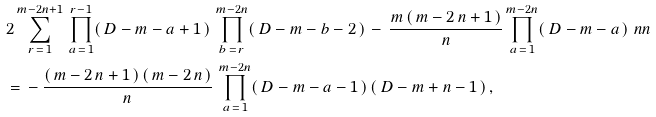<formula> <loc_0><loc_0><loc_500><loc_500>& 2 \sum _ { r \, = \, 1 } ^ { m - 2 n + 1 } \, \prod _ { a \, = \, 1 } ^ { r - 1 } ( \, D - m - a + 1 \, ) \, \prod _ { b \, = \, r } ^ { m - 2 n } ( \, D - m - b - 2 \, ) \, - \, \frac { m \, ( \, m - 2 \, n + 1 \, ) } { n } \prod _ { a \, = \, 1 } ^ { m - 2 n } ( \, D - m - a \, ) \ n n \\ & = \, - \, \frac { ( \, m - 2 \, n + 1 \, ) \, ( \, m - 2 \, n \, ) } { n } \, \prod _ { a \, = \, 1 } ^ { m - 2 n } ( \, D - m - a - 1 \, ) \, ( \, D - m + n - 1 \, ) \, ,</formula> 